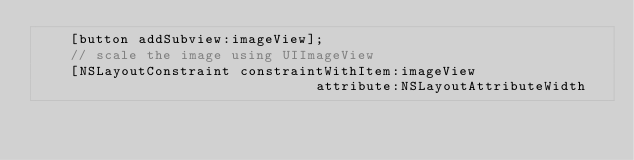Convert code to text. <code><loc_0><loc_0><loc_500><loc_500><_ObjectiveC_>    [button addSubview:imageView];
    // scale the image using UIImageView
    [NSLayoutConstraint constraintWithItem:imageView
                                 attribute:NSLayoutAttributeWidth</code> 